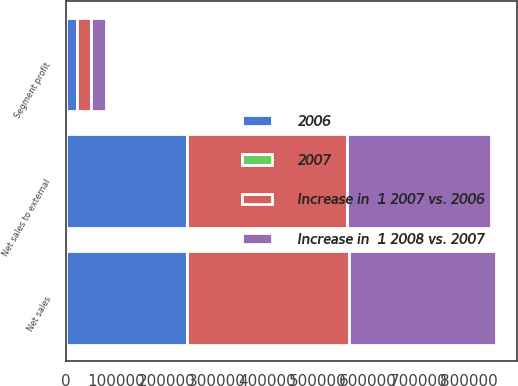<chart> <loc_0><loc_0><loc_500><loc_500><stacked_bar_chart><ecel><fcel>Net sales<fcel>Net sales to external<fcel>Segment profit<nl><fcel>Increase in  1 2007 vs. 2006<fcel>321480<fcel>316203<fcel>28809<nl><fcel>Increase in  1 2008 vs. 2007<fcel>290330<fcel>286617<fcel>29887<nl><fcel>2006<fcel>240869<fcel>240869<fcel>21412<nl><fcel>2007<fcel>11<fcel>10<fcel>4<nl></chart> 